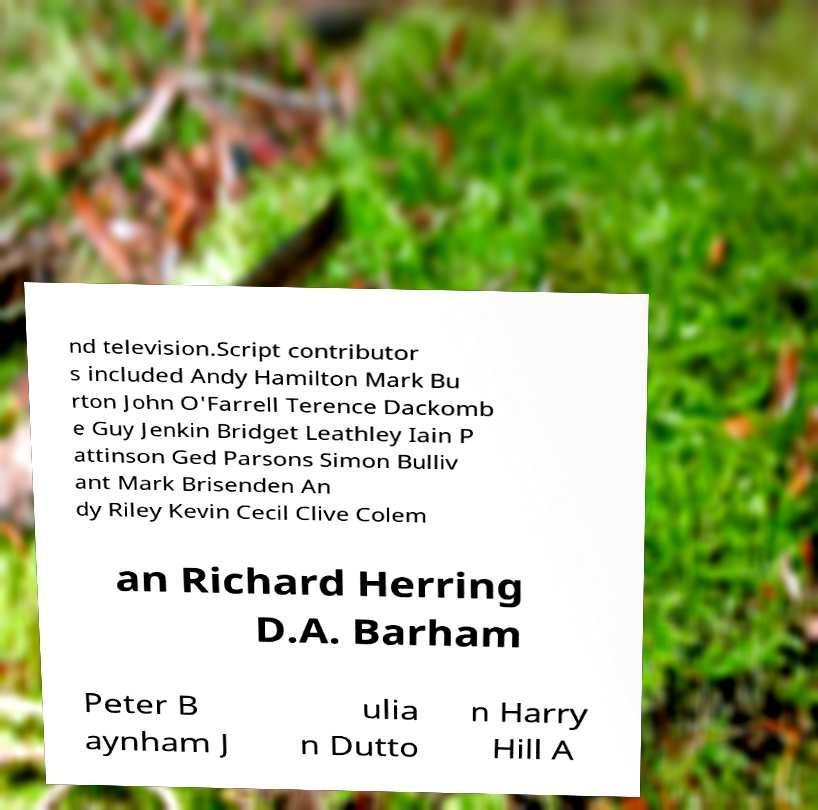Please identify and transcribe the text found in this image. nd television.Script contributor s included Andy Hamilton Mark Bu rton John O'Farrell Terence Dackomb e Guy Jenkin Bridget Leathley Iain P attinson Ged Parsons Simon Bulliv ant Mark Brisenden An dy Riley Kevin Cecil Clive Colem an Richard Herring D.A. Barham Peter B aynham J ulia n Dutto n Harry Hill A 